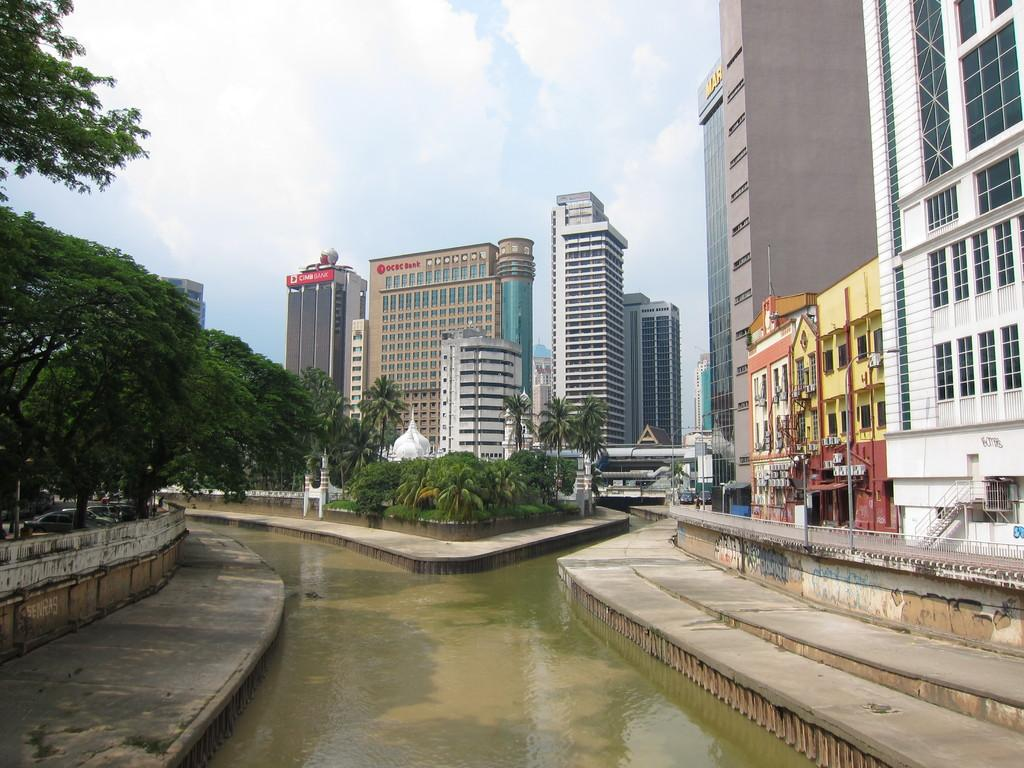What type of structures can be seen in the image? There are buildings in the image. What feature do the buildings have? The buildings have windows. What natural element is visible in the image? There is water visible in the image. What type of vegetation can be seen in the image? There are plants, grass, and trees in the image. What man-made object is present in the image? There is a light pole in the image. What architectural feature is present in the image? There is a fence in the image. What mode of transportation can be seen in the image? There are vehicles in the image. What is the weather like in the image? The sky is cloudy in the image. What type of spoon is being used to create harmony in the image? There is no spoon or concept of harmony present in the image. How does the comfort level of the plants affect the growth of the trees in the image? There is no indication of the comfort level of the plants or its effect on the growth of the trees in the image. 